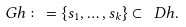Convert formula to latex. <formula><loc_0><loc_0><loc_500><loc_500>\ G h \colon = \{ s _ { 1 } , \dots , s _ { k } \} \subset \ D h .</formula> 